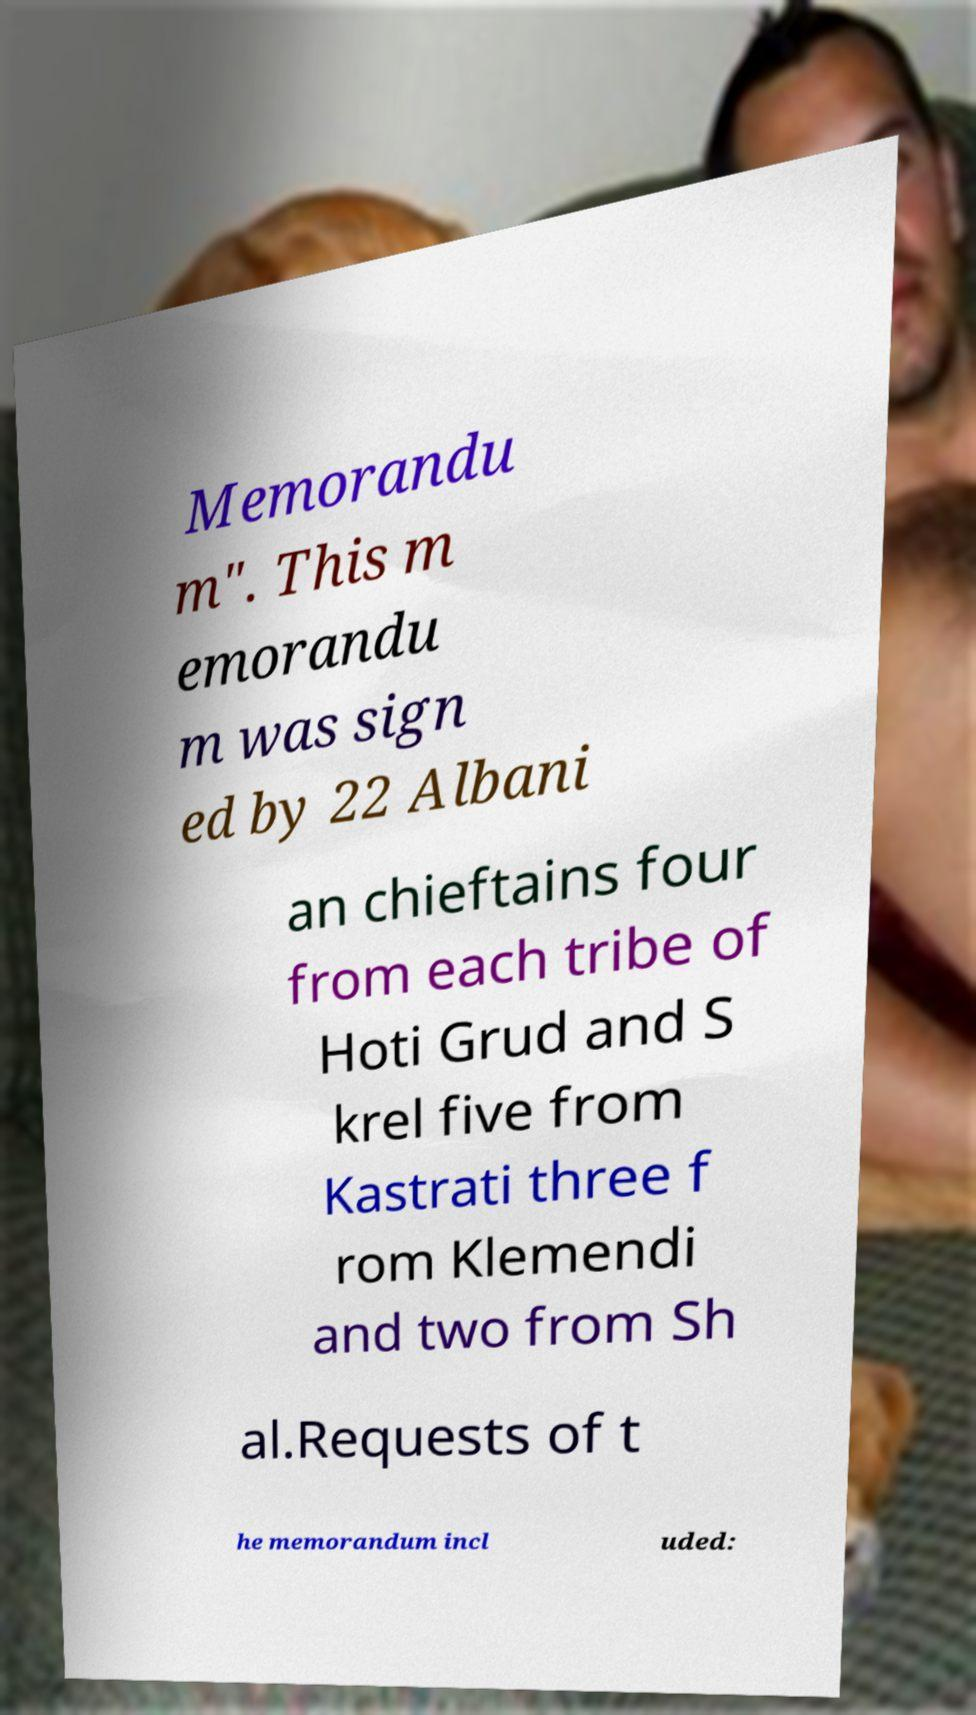What messages or text are displayed in this image? I need them in a readable, typed format. Memorandu m". This m emorandu m was sign ed by 22 Albani an chieftains four from each tribe of Hoti Grud and S krel five from Kastrati three f rom Klemendi and two from Sh al.Requests of t he memorandum incl uded: 